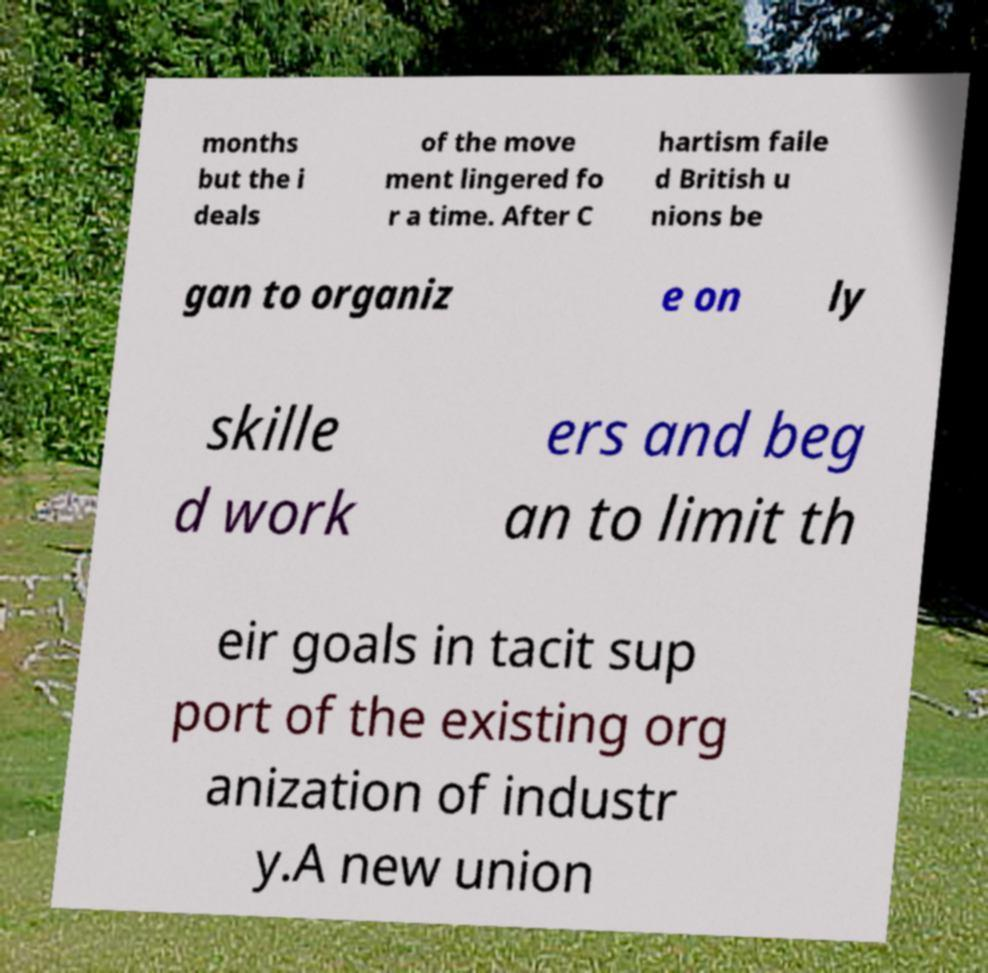I need the written content from this picture converted into text. Can you do that? months but the i deals of the move ment lingered fo r a time. After C hartism faile d British u nions be gan to organiz e on ly skille d work ers and beg an to limit th eir goals in tacit sup port of the existing org anization of industr y.A new union 